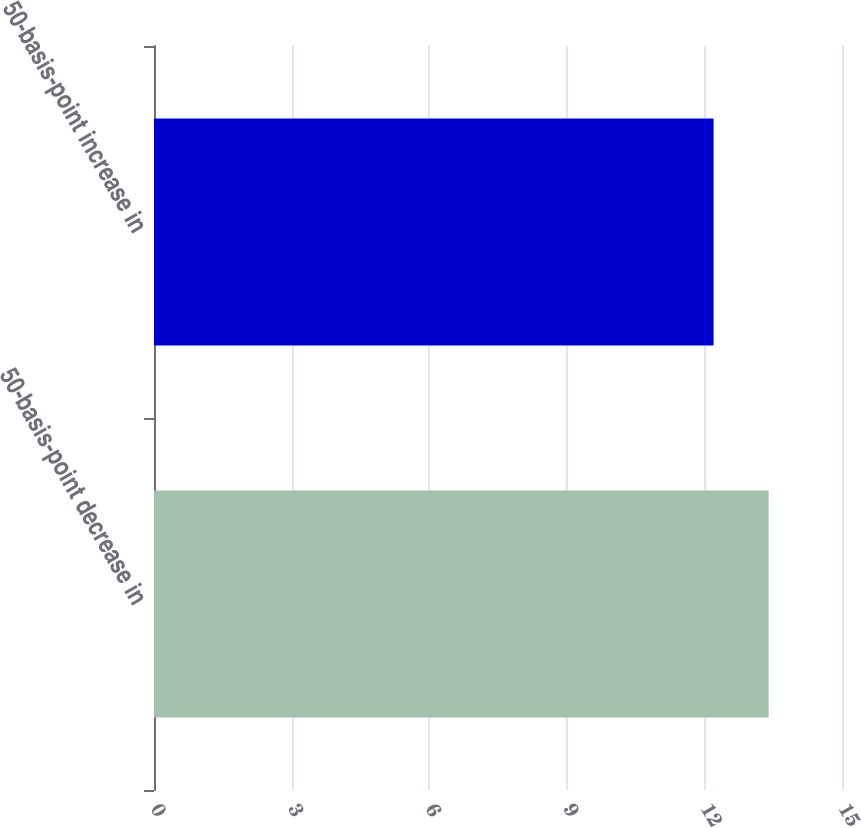<chart> <loc_0><loc_0><loc_500><loc_500><bar_chart><fcel>50-basis-point decrease in<fcel>50-basis-point increase in<nl><fcel>13.4<fcel>12.2<nl></chart> 